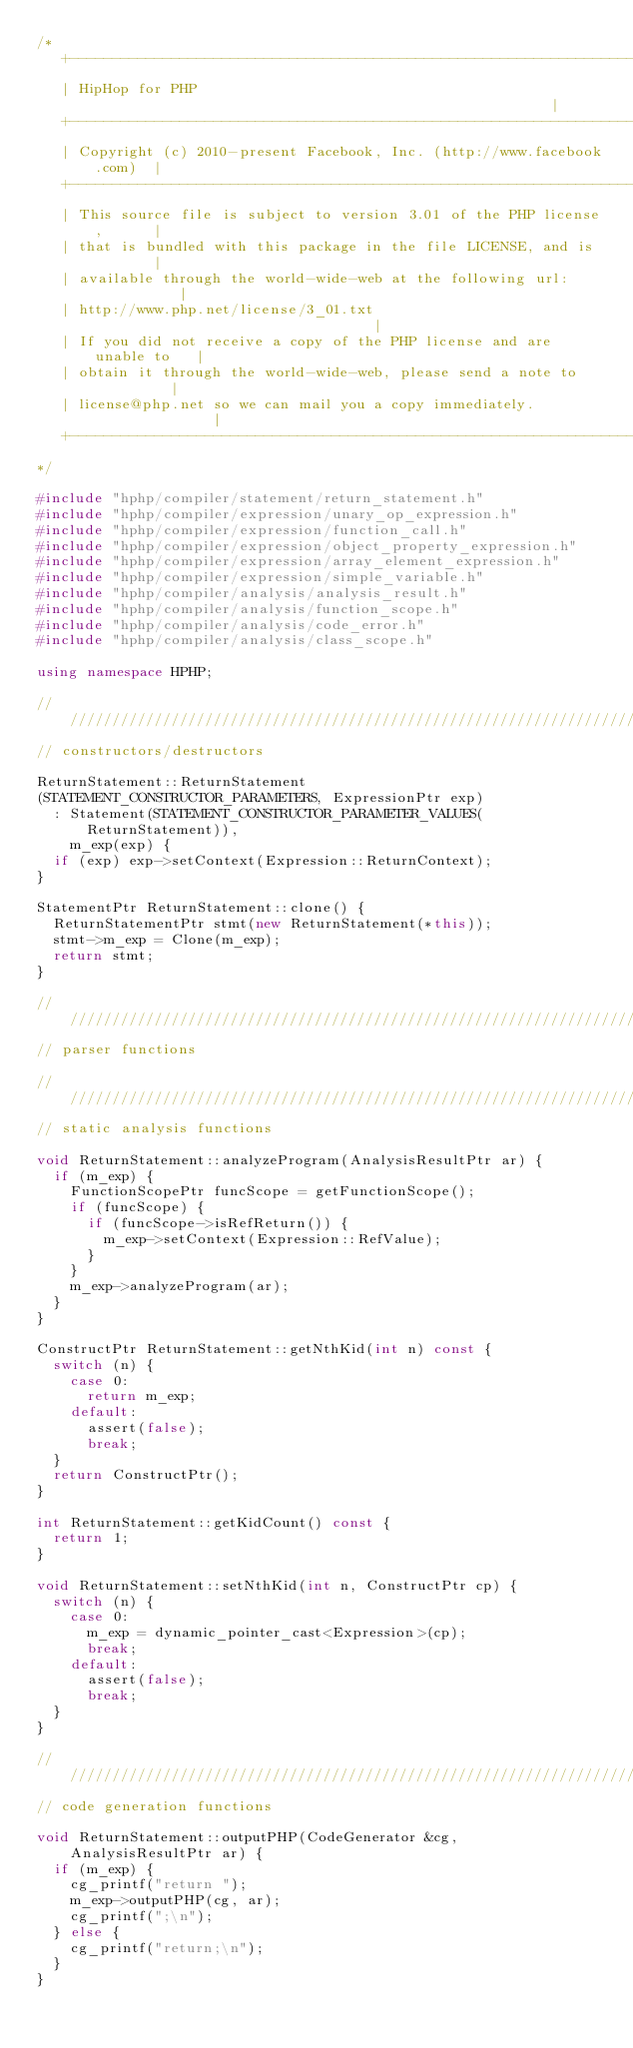Convert code to text. <code><loc_0><loc_0><loc_500><loc_500><_C++_>/*
   +----------------------------------------------------------------------+
   | HipHop for PHP                                                       |
   +----------------------------------------------------------------------+
   | Copyright (c) 2010-present Facebook, Inc. (http://www.facebook.com)  |
   +----------------------------------------------------------------------+
   | This source file is subject to version 3.01 of the PHP license,      |
   | that is bundled with this package in the file LICENSE, and is        |
   | available through the world-wide-web at the following url:           |
   | http://www.php.net/license/3_01.txt                                  |
   | If you did not receive a copy of the PHP license and are unable to   |
   | obtain it through the world-wide-web, please send a note to          |
   | license@php.net so we can mail you a copy immediately.               |
   +----------------------------------------------------------------------+
*/

#include "hphp/compiler/statement/return_statement.h"
#include "hphp/compiler/expression/unary_op_expression.h"
#include "hphp/compiler/expression/function_call.h"
#include "hphp/compiler/expression/object_property_expression.h"
#include "hphp/compiler/expression/array_element_expression.h"
#include "hphp/compiler/expression/simple_variable.h"
#include "hphp/compiler/analysis/analysis_result.h"
#include "hphp/compiler/analysis/function_scope.h"
#include "hphp/compiler/analysis/code_error.h"
#include "hphp/compiler/analysis/class_scope.h"

using namespace HPHP;

///////////////////////////////////////////////////////////////////////////////
// constructors/destructors

ReturnStatement::ReturnStatement
(STATEMENT_CONSTRUCTOR_PARAMETERS, ExpressionPtr exp)
  : Statement(STATEMENT_CONSTRUCTOR_PARAMETER_VALUES(ReturnStatement)),
    m_exp(exp) {
  if (exp) exp->setContext(Expression::ReturnContext);
}

StatementPtr ReturnStatement::clone() {
  ReturnStatementPtr stmt(new ReturnStatement(*this));
  stmt->m_exp = Clone(m_exp);
  return stmt;
}

///////////////////////////////////////////////////////////////////////////////
// parser functions

///////////////////////////////////////////////////////////////////////////////
// static analysis functions

void ReturnStatement::analyzeProgram(AnalysisResultPtr ar) {
  if (m_exp) {
    FunctionScopePtr funcScope = getFunctionScope();
    if (funcScope) {
      if (funcScope->isRefReturn()) {
        m_exp->setContext(Expression::RefValue);
      }
    }
    m_exp->analyzeProgram(ar);
  }
}

ConstructPtr ReturnStatement::getNthKid(int n) const {
  switch (n) {
    case 0:
      return m_exp;
    default:
      assert(false);
      break;
  }
  return ConstructPtr();
}

int ReturnStatement::getKidCount() const {
  return 1;
}

void ReturnStatement::setNthKid(int n, ConstructPtr cp) {
  switch (n) {
    case 0:
      m_exp = dynamic_pointer_cast<Expression>(cp);
      break;
    default:
      assert(false);
      break;
  }
}

///////////////////////////////////////////////////////////////////////////////
// code generation functions

void ReturnStatement::outputPHP(CodeGenerator &cg, AnalysisResultPtr ar) {
  if (m_exp) {
    cg_printf("return ");
    m_exp->outputPHP(cg, ar);
    cg_printf(";\n");
  } else {
    cg_printf("return;\n");
  }
}
</code> 